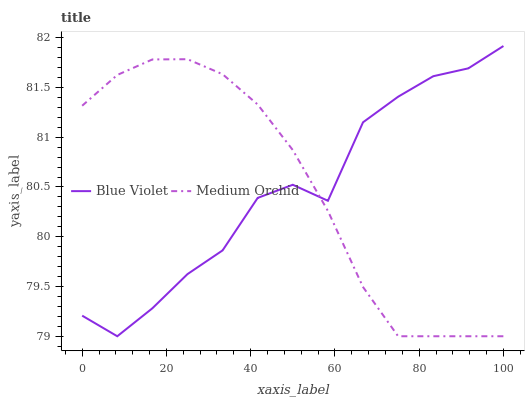Does Blue Violet have the minimum area under the curve?
Answer yes or no. Yes. Does Medium Orchid have the maximum area under the curve?
Answer yes or no. Yes. Does Blue Violet have the maximum area under the curve?
Answer yes or no. No. Is Medium Orchid the smoothest?
Answer yes or no. Yes. Is Blue Violet the roughest?
Answer yes or no. Yes. Is Blue Violet the smoothest?
Answer yes or no. No. Does Medium Orchid have the lowest value?
Answer yes or no. Yes. Does Blue Violet have the highest value?
Answer yes or no. Yes. Does Blue Violet intersect Medium Orchid?
Answer yes or no. Yes. Is Blue Violet less than Medium Orchid?
Answer yes or no. No. Is Blue Violet greater than Medium Orchid?
Answer yes or no. No. 